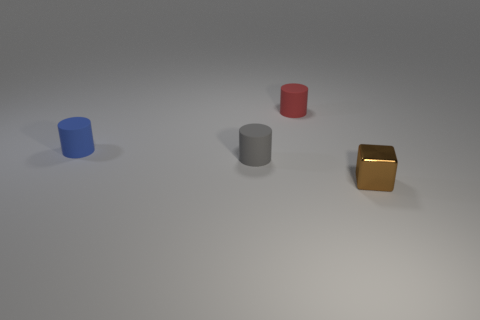Subtract all gray cylinders. How many cylinders are left? 2 Add 4 green rubber spheres. How many objects exist? 8 Subtract all red cylinders. How many cylinders are left? 2 Subtract all cubes. How many objects are left? 3 Subtract 2 cylinders. How many cylinders are left? 1 Add 2 tiny blocks. How many tiny blocks are left? 3 Add 3 small metal cubes. How many small metal cubes exist? 4 Subtract 0 purple cylinders. How many objects are left? 4 Subtract all purple cylinders. Subtract all gray blocks. How many cylinders are left? 3 Subtract all cyan shiny objects. Subtract all small red matte cylinders. How many objects are left? 3 